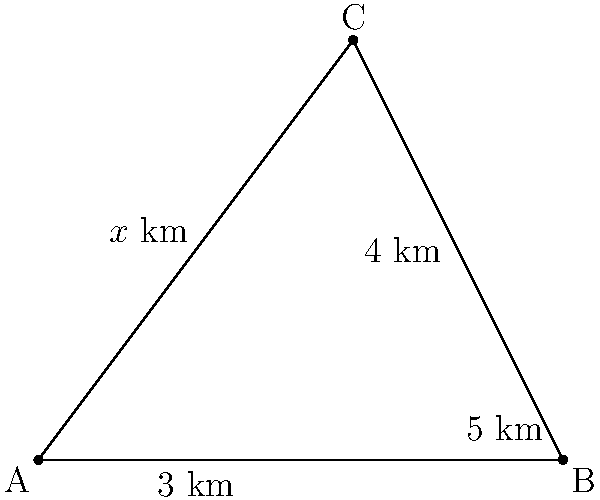As a journalist reporting on a disputed territory between two nations, you've obtained information about three observation points (A, B, and C) used for triangulation. Point A is 3 km from point B, and point C is 4 km directly north of the midpoint between A and B. If the distance between points A and C is 5 km, estimate the area of the triangular region formed by these three points. How might this information be useful in your reporting on the territorial dispute? Let's approach this step-by-step:

1) We have a right-angled triangle with the following known measurements:
   - The base (AB) is 3 km
   - The height (from the midpoint of AB to C) is 4 km
   - The hypotenuse (AC) is 5 km

2) To calculate the area, we need to use the formula for the area of a triangle:
   $$\text{Area} = \frac{1}{2} \times \text{base} \times \text{height}$$

3) We have all the information we need:
   $$\text{Area} = \frac{1}{2} \times 3 \text{ km} \times 4 \text{ km}$$

4) Calculating:
   $$\text{Area} = \frac{1}{2} \times 12 \text{ km}^2 = 6 \text{ km}^2$$

5) This information can be useful in reporting on the territorial dispute in several ways:
   - It provides a precise measurement of the disputed area
   - It demonstrates the use of triangulation in border disputes
   - It gives context to the scale of the dispute
   - It can be used to compare with other territorial claims or disputes

6) As a journalist, you could use this information to provide factual, quantitative data in your report, helping readers understand the scale of the dispute and the methods used in territorial mapping.
Answer: 6 km² 